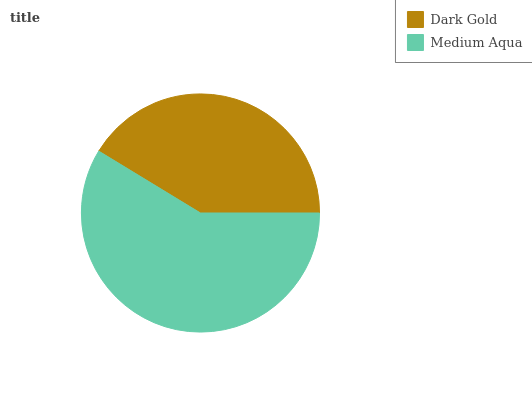Is Dark Gold the minimum?
Answer yes or no. Yes. Is Medium Aqua the maximum?
Answer yes or no. Yes. Is Medium Aqua the minimum?
Answer yes or no. No. Is Medium Aqua greater than Dark Gold?
Answer yes or no. Yes. Is Dark Gold less than Medium Aqua?
Answer yes or no. Yes. Is Dark Gold greater than Medium Aqua?
Answer yes or no. No. Is Medium Aqua less than Dark Gold?
Answer yes or no. No. Is Medium Aqua the high median?
Answer yes or no. Yes. Is Dark Gold the low median?
Answer yes or no. Yes. Is Dark Gold the high median?
Answer yes or no. No. Is Medium Aqua the low median?
Answer yes or no. No. 